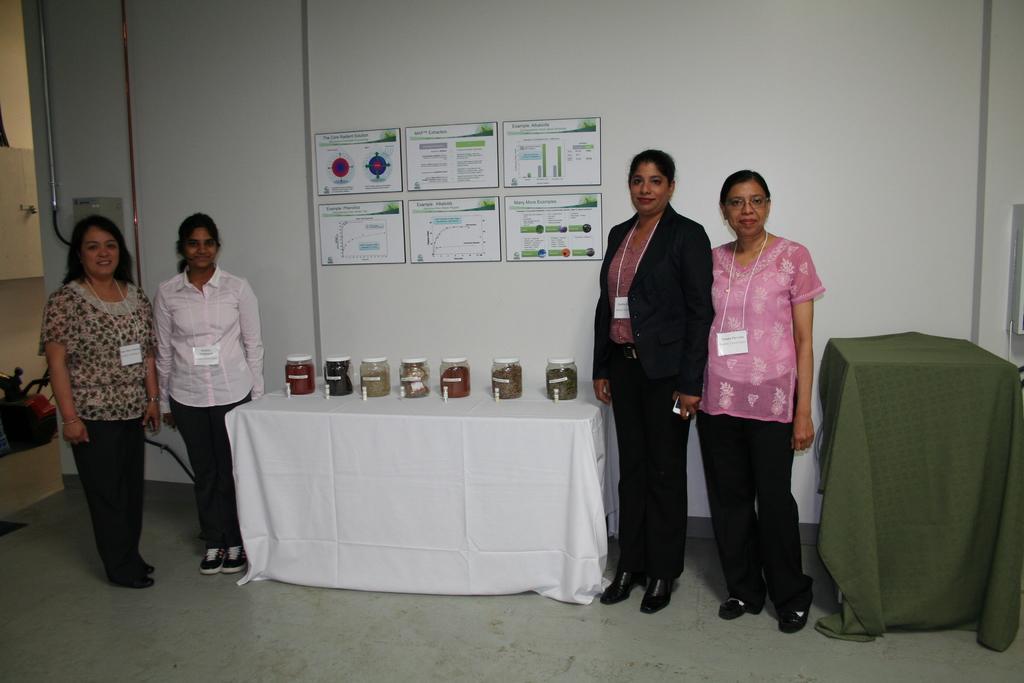How would you summarize this image in a sentence or two? In this image I can see the floor, few persons standing on the floor, few glass jars on the white colored table and few other objects. In the background I can see the white colored wall and few posters to the wall. 